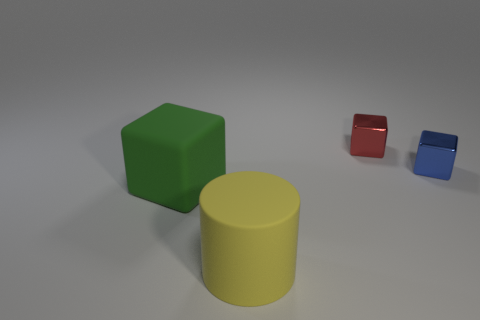Subtract all cyan blocks. Subtract all gray cylinders. How many blocks are left? 3 Add 1 big cylinders. How many objects exist? 5 Subtract all blocks. How many objects are left? 1 Add 3 big yellow things. How many big yellow things exist? 4 Subtract 0 purple spheres. How many objects are left? 4 Subtract all small objects. Subtract all small gray objects. How many objects are left? 2 Add 3 cubes. How many cubes are left? 6 